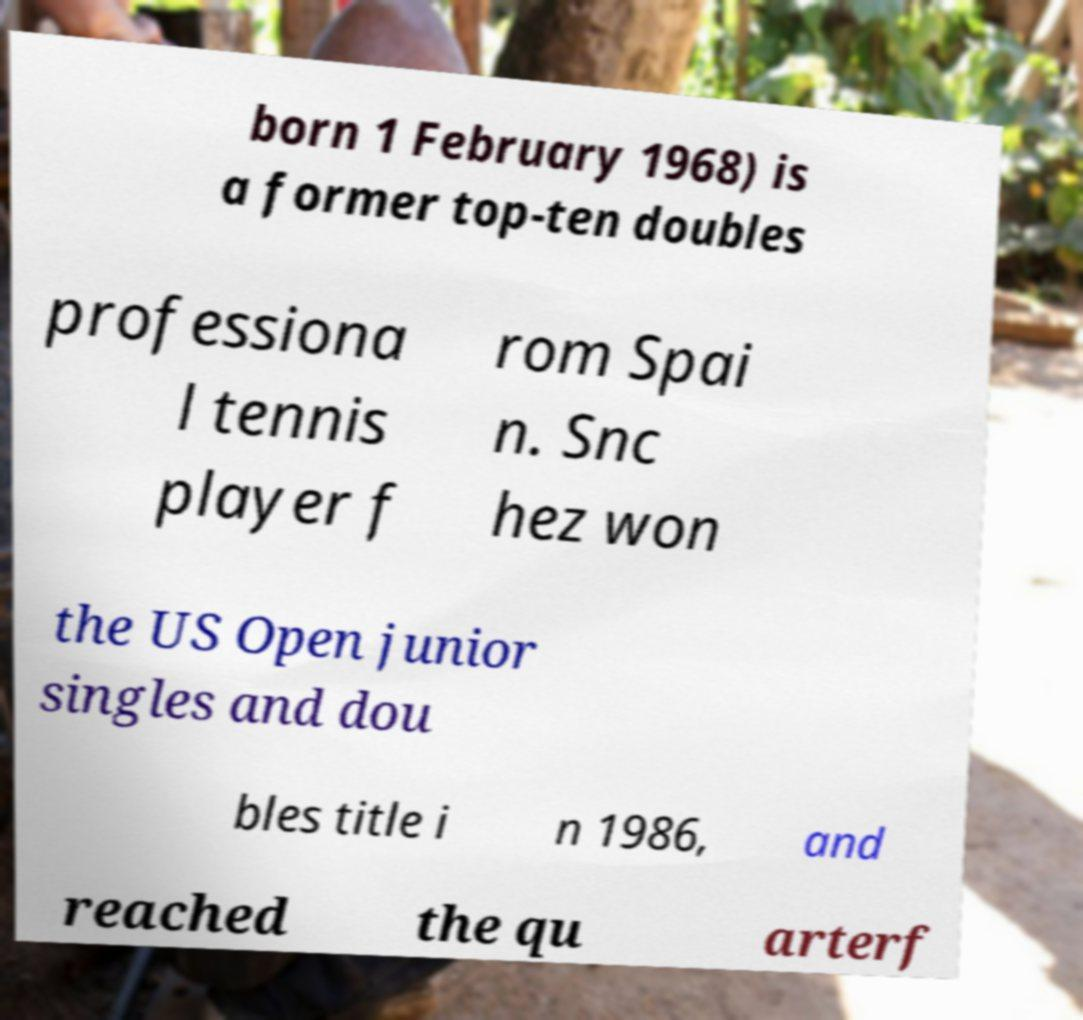Please identify and transcribe the text found in this image. born 1 February 1968) is a former top-ten doubles professiona l tennis player f rom Spai n. Snc hez won the US Open junior singles and dou bles title i n 1986, and reached the qu arterf 